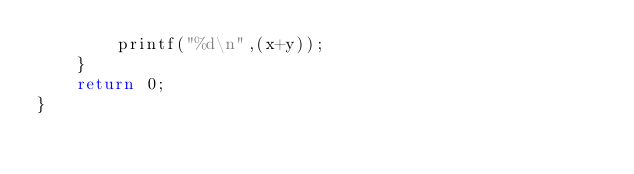Convert code to text. <code><loc_0><loc_0><loc_500><loc_500><_C_>        printf("%d\n",(x+y));
    }
    return 0;
}
                    </code> 